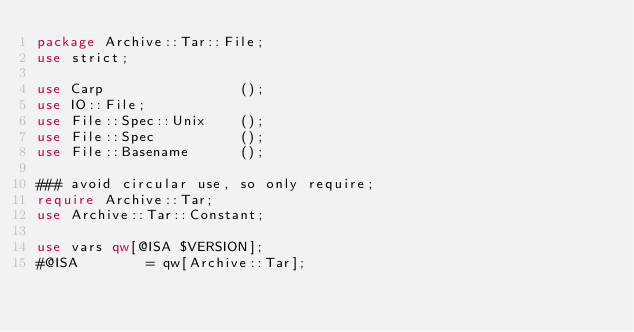<code> <loc_0><loc_0><loc_500><loc_500><_Perl_>package Archive::Tar::File;
use strict;

use Carp                ();
use IO::File;
use File::Spec::Unix    ();
use File::Spec          ();
use File::Basename      ();

### avoid circular use, so only require;
require Archive::Tar;
use Archive::Tar::Constant;

use vars qw[@ISA $VERSION];
#@ISA        = qw[Archive::Tar];</code> 